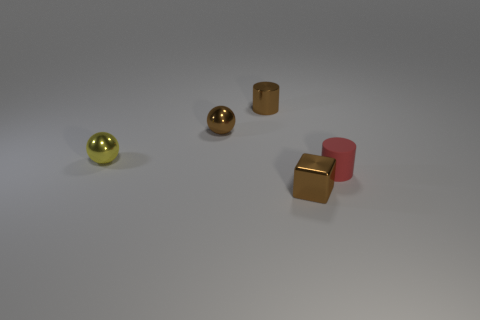Add 1 small red rubber objects. How many objects exist? 6 Subtract all yellow balls. How many balls are left? 1 Subtract all cubes. How many objects are left? 4 Subtract 1 blocks. How many blocks are left? 0 Subtract all gray spheres. Subtract all purple cylinders. How many spheres are left? 2 Subtract all brown balls. How many red cubes are left? 0 Subtract all small brown cubes. Subtract all tiny yellow spheres. How many objects are left? 3 Add 2 red cylinders. How many red cylinders are left? 3 Add 4 brown metallic objects. How many brown metallic objects exist? 7 Subtract 0 green balls. How many objects are left? 5 